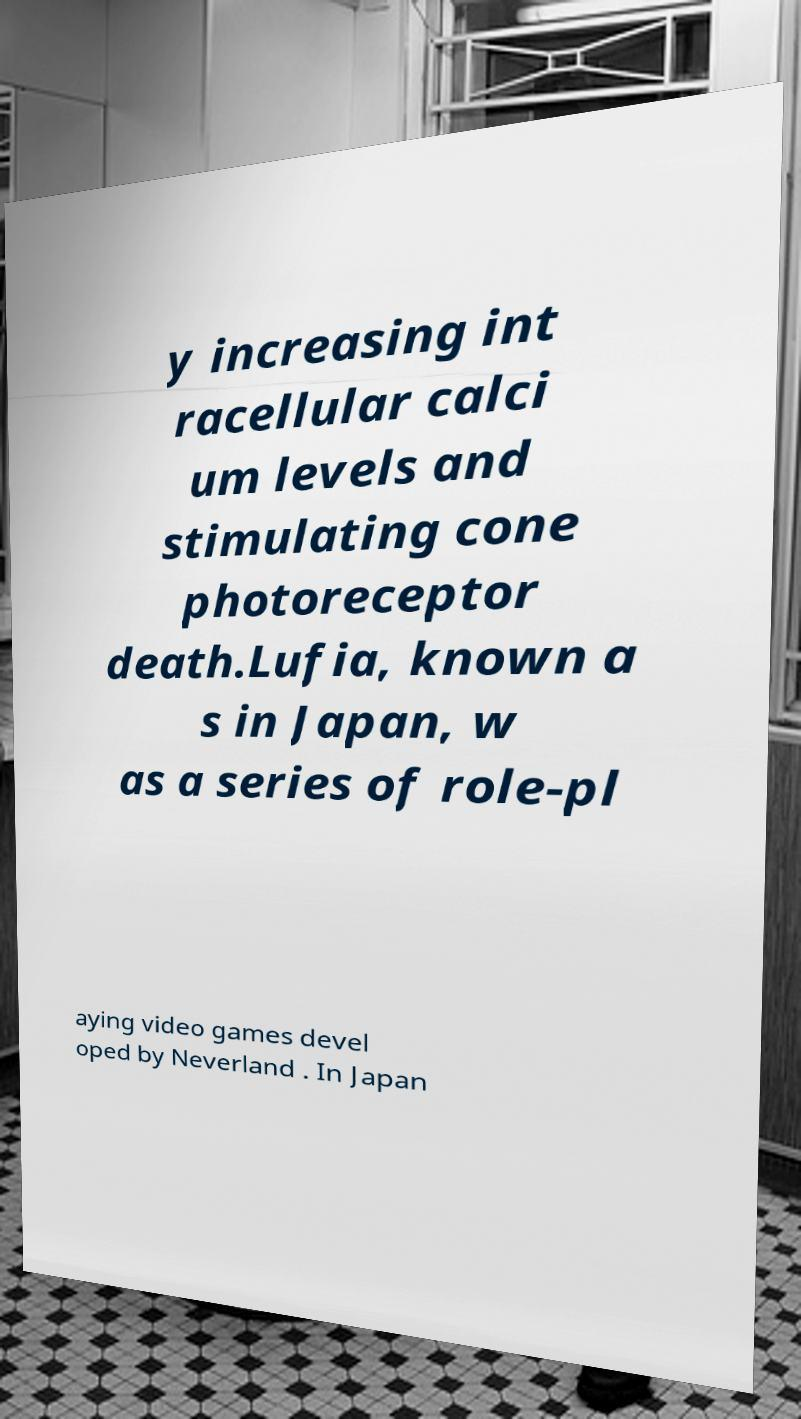What messages or text are displayed in this image? I need them in a readable, typed format. y increasing int racellular calci um levels and stimulating cone photoreceptor death.Lufia, known a s in Japan, w as a series of role-pl aying video games devel oped by Neverland . In Japan 